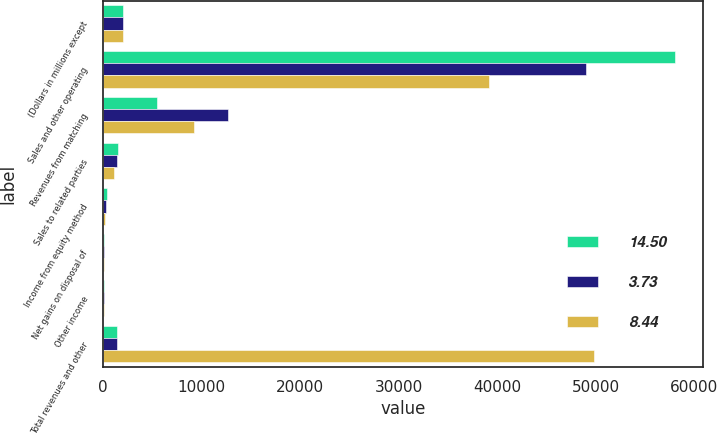Convert chart to OTSL. <chart><loc_0><loc_0><loc_500><loc_500><stacked_bar_chart><ecel><fcel>(Dollars in millions except<fcel>Sales and other operating<fcel>Revenues from matching<fcel>Sales to related parties<fcel>Income from equity method<fcel>Net gains on disposal of<fcel>Other income<fcel>Total revenues and other<nl><fcel>14.5<fcel>2006<fcel>57973<fcel>5457<fcel>1466<fcel>391<fcel>77<fcel>85<fcel>1434<nl><fcel>3.73<fcel>2005<fcel>48948<fcel>12636<fcel>1402<fcel>265<fcel>57<fcel>37<fcel>1434<nl><fcel>8.44<fcel>2004<fcel>39172<fcel>9242<fcel>1051<fcel>167<fcel>36<fcel>100<fcel>49770<nl></chart> 